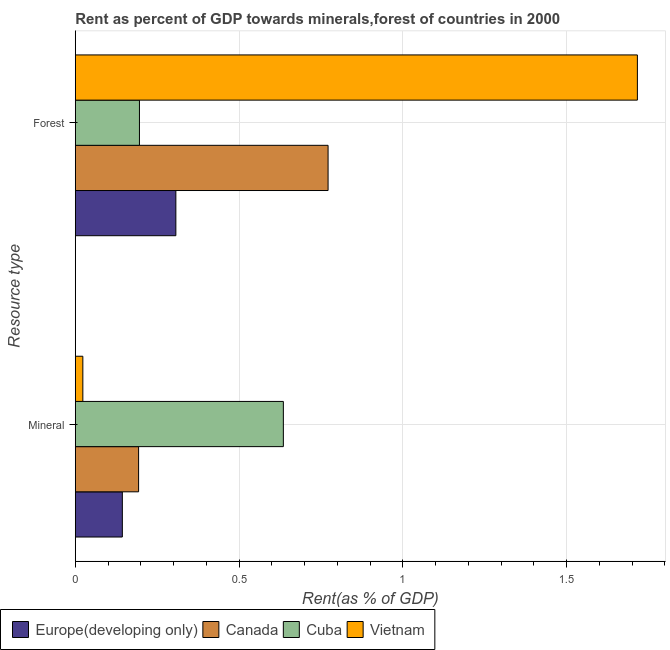Are the number of bars per tick equal to the number of legend labels?
Offer a very short reply. Yes. What is the label of the 2nd group of bars from the top?
Offer a very short reply. Mineral. What is the forest rent in Vietnam?
Give a very brief answer. 1.72. Across all countries, what is the maximum forest rent?
Your response must be concise. 1.72. Across all countries, what is the minimum mineral rent?
Provide a short and direct response. 0.02. In which country was the forest rent maximum?
Provide a short and direct response. Vietnam. In which country was the mineral rent minimum?
Offer a very short reply. Vietnam. What is the total mineral rent in the graph?
Your answer should be very brief. 1. What is the difference between the mineral rent in Europe(developing only) and that in Vietnam?
Your answer should be compact. 0.12. What is the difference between the forest rent in Canada and the mineral rent in Cuba?
Your answer should be compact. 0.14. What is the average forest rent per country?
Provide a short and direct response. 0.75. What is the difference between the mineral rent and forest rent in Canada?
Keep it short and to the point. -0.58. What is the ratio of the forest rent in Canada to that in Cuba?
Your response must be concise. 3.94. What does the 2nd bar from the top in Forest represents?
Your answer should be compact. Cuba. What does the 2nd bar from the bottom in Forest represents?
Your answer should be compact. Canada. What is the difference between two consecutive major ticks on the X-axis?
Give a very brief answer. 0.5. Are the values on the major ticks of X-axis written in scientific E-notation?
Give a very brief answer. No. Does the graph contain any zero values?
Provide a short and direct response. No. Does the graph contain grids?
Provide a short and direct response. Yes. Where does the legend appear in the graph?
Ensure brevity in your answer.  Bottom left. How many legend labels are there?
Ensure brevity in your answer.  4. How are the legend labels stacked?
Ensure brevity in your answer.  Horizontal. What is the title of the graph?
Ensure brevity in your answer.  Rent as percent of GDP towards minerals,forest of countries in 2000. What is the label or title of the X-axis?
Offer a very short reply. Rent(as % of GDP). What is the label or title of the Y-axis?
Make the answer very short. Resource type. What is the Rent(as % of GDP) in Europe(developing only) in Mineral?
Offer a terse response. 0.14. What is the Rent(as % of GDP) in Canada in Mineral?
Offer a terse response. 0.19. What is the Rent(as % of GDP) in Cuba in Mineral?
Your answer should be compact. 0.64. What is the Rent(as % of GDP) of Vietnam in Mineral?
Offer a terse response. 0.02. What is the Rent(as % of GDP) in Europe(developing only) in Forest?
Provide a short and direct response. 0.31. What is the Rent(as % of GDP) in Canada in Forest?
Offer a very short reply. 0.77. What is the Rent(as % of GDP) of Cuba in Forest?
Offer a terse response. 0.2. What is the Rent(as % of GDP) of Vietnam in Forest?
Offer a terse response. 1.72. Across all Resource type, what is the maximum Rent(as % of GDP) in Europe(developing only)?
Provide a short and direct response. 0.31. Across all Resource type, what is the maximum Rent(as % of GDP) in Canada?
Your answer should be very brief. 0.77. Across all Resource type, what is the maximum Rent(as % of GDP) in Cuba?
Provide a succinct answer. 0.64. Across all Resource type, what is the maximum Rent(as % of GDP) of Vietnam?
Provide a short and direct response. 1.72. Across all Resource type, what is the minimum Rent(as % of GDP) in Europe(developing only)?
Keep it short and to the point. 0.14. Across all Resource type, what is the minimum Rent(as % of GDP) in Canada?
Keep it short and to the point. 0.19. Across all Resource type, what is the minimum Rent(as % of GDP) in Cuba?
Ensure brevity in your answer.  0.2. Across all Resource type, what is the minimum Rent(as % of GDP) in Vietnam?
Your answer should be compact. 0.02. What is the total Rent(as % of GDP) of Europe(developing only) in the graph?
Provide a succinct answer. 0.45. What is the total Rent(as % of GDP) of Cuba in the graph?
Offer a terse response. 0.83. What is the total Rent(as % of GDP) in Vietnam in the graph?
Make the answer very short. 1.74. What is the difference between the Rent(as % of GDP) of Europe(developing only) in Mineral and that in Forest?
Your response must be concise. -0.16. What is the difference between the Rent(as % of GDP) of Canada in Mineral and that in Forest?
Provide a short and direct response. -0.58. What is the difference between the Rent(as % of GDP) in Cuba in Mineral and that in Forest?
Provide a succinct answer. 0.44. What is the difference between the Rent(as % of GDP) in Vietnam in Mineral and that in Forest?
Make the answer very short. -1.69. What is the difference between the Rent(as % of GDP) of Europe(developing only) in Mineral and the Rent(as % of GDP) of Canada in Forest?
Your answer should be compact. -0.63. What is the difference between the Rent(as % of GDP) in Europe(developing only) in Mineral and the Rent(as % of GDP) in Cuba in Forest?
Ensure brevity in your answer.  -0.05. What is the difference between the Rent(as % of GDP) in Europe(developing only) in Mineral and the Rent(as % of GDP) in Vietnam in Forest?
Provide a succinct answer. -1.57. What is the difference between the Rent(as % of GDP) in Canada in Mineral and the Rent(as % of GDP) in Cuba in Forest?
Provide a short and direct response. -0. What is the difference between the Rent(as % of GDP) of Canada in Mineral and the Rent(as % of GDP) of Vietnam in Forest?
Ensure brevity in your answer.  -1.52. What is the difference between the Rent(as % of GDP) of Cuba in Mineral and the Rent(as % of GDP) of Vietnam in Forest?
Your response must be concise. -1.08. What is the average Rent(as % of GDP) of Europe(developing only) per Resource type?
Offer a terse response. 0.23. What is the average Rent(as % of GDP) of Canada per Resource type?
Provide a succinct answer. 0.48. What is the average Rent(as % of GDP) in Cuba per Resource type?
Give a very brief answer. 0.42. What is the average Rent(as % of GDP) of Vietnam per Resource type?
Keep it short and to the point. 0.87. What is the difference between the Rent(as % of GDP) in Europe(developing only) and Rent(as % of GDP) in Canada in Mineral?
Provide a succinct answer. -0.05. What is the difference between the Rent(as % of GDP) of Europe(developing only) and Rent(as % of GDP) of Cuba in Mineral?
Provide a short and direct response. -0.49. What is the difference between the Rent(as % of GDP) in Europe(developing only) and Rent(as % of GDP) in Vietnam in Mineral?
Provide a short and direct response. 0.12. What is the difference between the Rent(as % of GDP) of Canada and Rent(as % of GDP) of Cuba in Mineral?
Your response must be concise. -0.44. What is the difference between the Rent(as % of GDP) of Canada and Rent(as % of GDP) of Vietnam in Mineral?
Make the answer very short. 0.17. What is the difference between the Rent(as % of GDP) of Cuba and Rent(as % of GDP) of Vietnam in Mineral?
Offer a terse response. 0.61. What is the difference between the Rent(as % of GDP) of Europe(developing only) and Rent(as % of GDP) of Canada in Forest?
Provide a succinct answer. -0.46. What is the difference between the Rent(as % of GDP) of Europe(developing only) and Rent(as % of GDP) of Cuba in Forest?
Make the answer very short. 0.11. What is the difference between the Rent(as % of GDP) in Europe(developing only) and Rent(as % of GDP) in Vietnam in Forest?
Make the answer very short. -1.41. What is the difference between the Rent(as % of GDP) in Canada and Rent(as % of GDP) in Cuba in Forest?
Your answer should be very brief. 0.58. What is the difference between the Rent(as % of GDP) in Canada and Rent(as % of GDP) in Vietnam in Forest?
Offer a terse response. -0.94. What is the difference between the Rent(as % of GDP) of Cuba and Rent(as % of GDP) of Vietnam in Forest?
Make the answer very short. -1.52. What is the ratio of the Rent(as % of GDP) in Europe(developing only) in Mineral to that in Forest?
Offer a very short reply. 0.47. What is the ratio of the Rent(as % of GDP) in Canada in Mineral to that in Forest?
Your answer should be compact. 0.25. What is the ratio of the Rent(as % of GDP) of Cuba in Mineral to that in Forest?
Provide a short and direct response. 3.24. What is the ratio of the Rent(as % of GDP) of Vietnam in Mineral to that in Forest?
Provide a short and direct response. 0.01. What is the difference between the highest and the second highest Rent(as % of GDP) in Europe(developing only)?
Provide a succinct answer. 0.16. What is the difference between the highest and the second highest Rent(as % of GDP) of Canada?
Give a very brief answer. 0.58. What is the difference between the highest and the second highest Rent(as % of GDP) of Cuba?
Give a very brief answer. 0.44. What is the difference between the highest and the second highest Rent(as % of GDP) of Vietnam?
Give a very brief answer. 1.69. What is the difference between the highest and the lowest Rent(as % of GDP) in Europe(developing only)?
Provide a succinct answer. 0.16. What is the difference between the highest and the lowest Rent(as % of GDP) of Canada?
Give a very brief answer. 0.58. What is the difference between the highest and the lowest Rent(as % of GDP) of Cuba?
Your response must be concise. 0.44. What is the difference between the highest and the lowest Rent(as % of GDP) of Vietnam?
Keep it short and to the point. 1.69. 